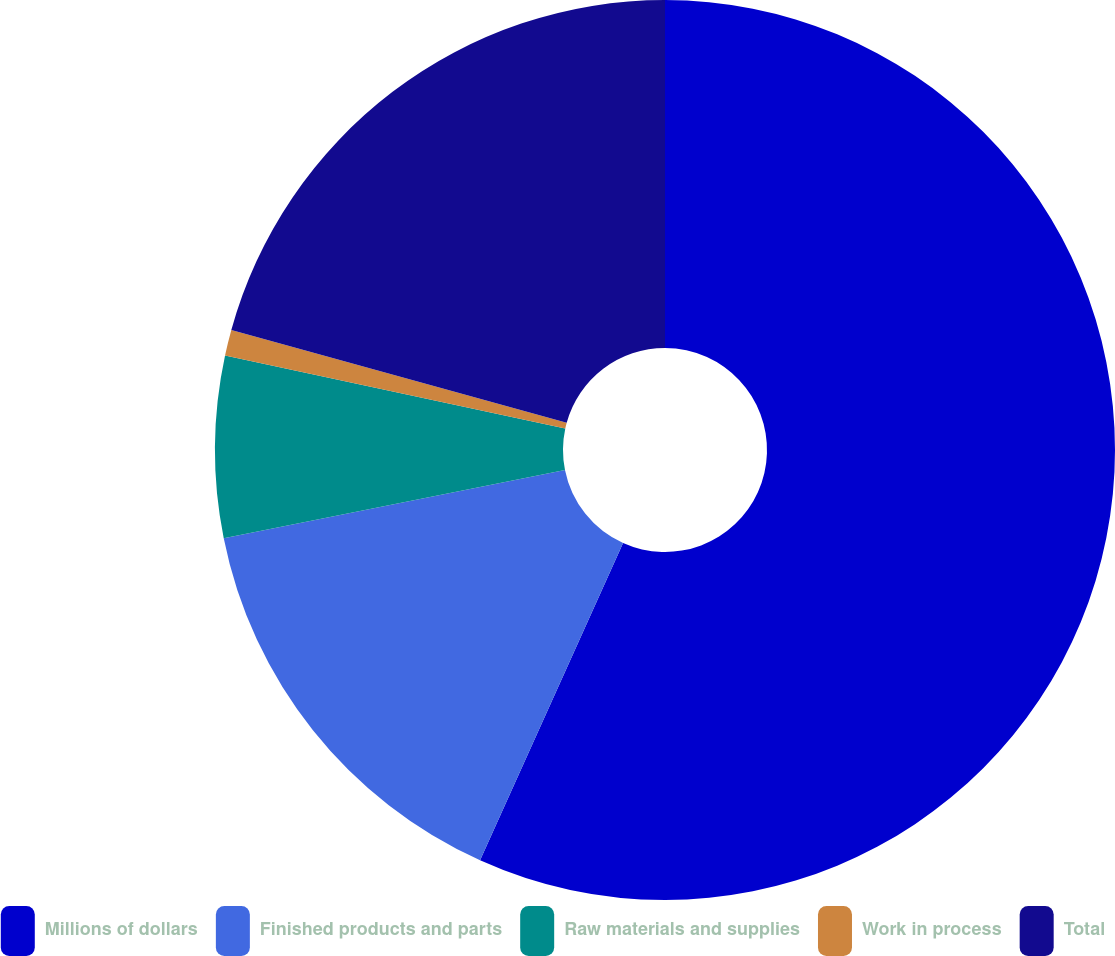Convert chart. <chart><loc_0><loc_0><loc_500><loc_500><pie_chart><fcel>Millions of dollars<fcel>Finished products and parts<fcel>Raw materials and supplies<fcel>Work in process<fcel>Total<nl><fcel>56.74%<fcel>15.12%<fcel>6.51%<fcel>0.93%<fcel>20.7%<nl></chart> 